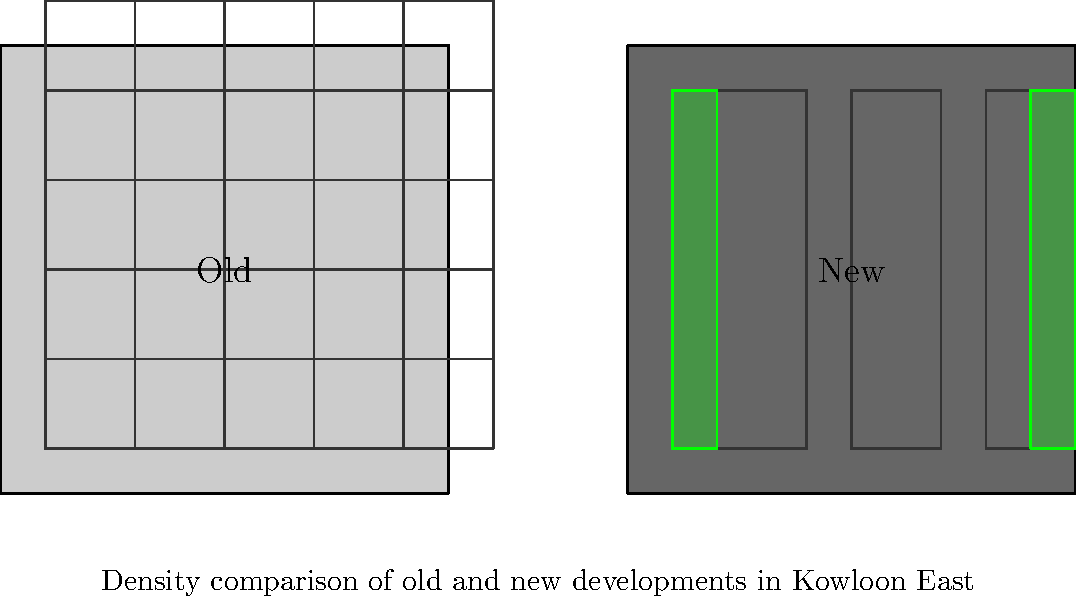Based on the diagram comparing old and new urban developments in Kowloon East, what are the key differences in terms of building density, height, and green space allocation? How do these differences reflect the principles of sustainable urban design? To answer this question, let's analyze the diagram step-by-step:

1. Building density:
   - Old development: Contains approximately 25 smaller buildings
   - New development: Features 3 larger buildings

2. Building height:
   - Old development: Buildings are uniformly short
   - New development: Buildings are significantly taller

3. Green space allocation:
   - Old development: No visible green spaces
   - New development: Two distinct green areas on either side of the buildings

4. Layout:
   - Old development: Grid-like pattern with uniform building sizes
   - New development: More varied layout with larger buildings and dedicated green spaces

5. Sustainable urban design principles reflected:
   a) Increased density: Taller buildings in the new development allow for more efficient land use
   b) Mixed-use development: Larger buildings can accommodate various functions (residential, commercial, office)
   c) Green space integration: Dedicated areas for vegetation improve air quality and provide recreational spaces
   d) Reduced urban sprawl: Vertical growth reduces the need for horizontal expansion

6. Benefits of the new design:
   - More efficient use of land
   - Potential for better energy efficiency in larger buildings
   - Improved quality of life with integrated green spaces
   - Possibility for better public transportation integration due to higher density

The new development in Kowloon East demonstrates a shift towards more sustainable urban design by emphasizing vertical growth, mixed-use development, and the integration of green spaces, which are key principles in modern sustainable urban planning.
Answer: Higher density, taller buildings, integrated green spaces 